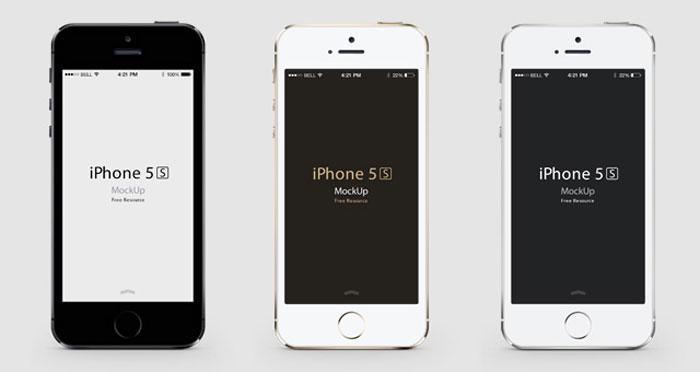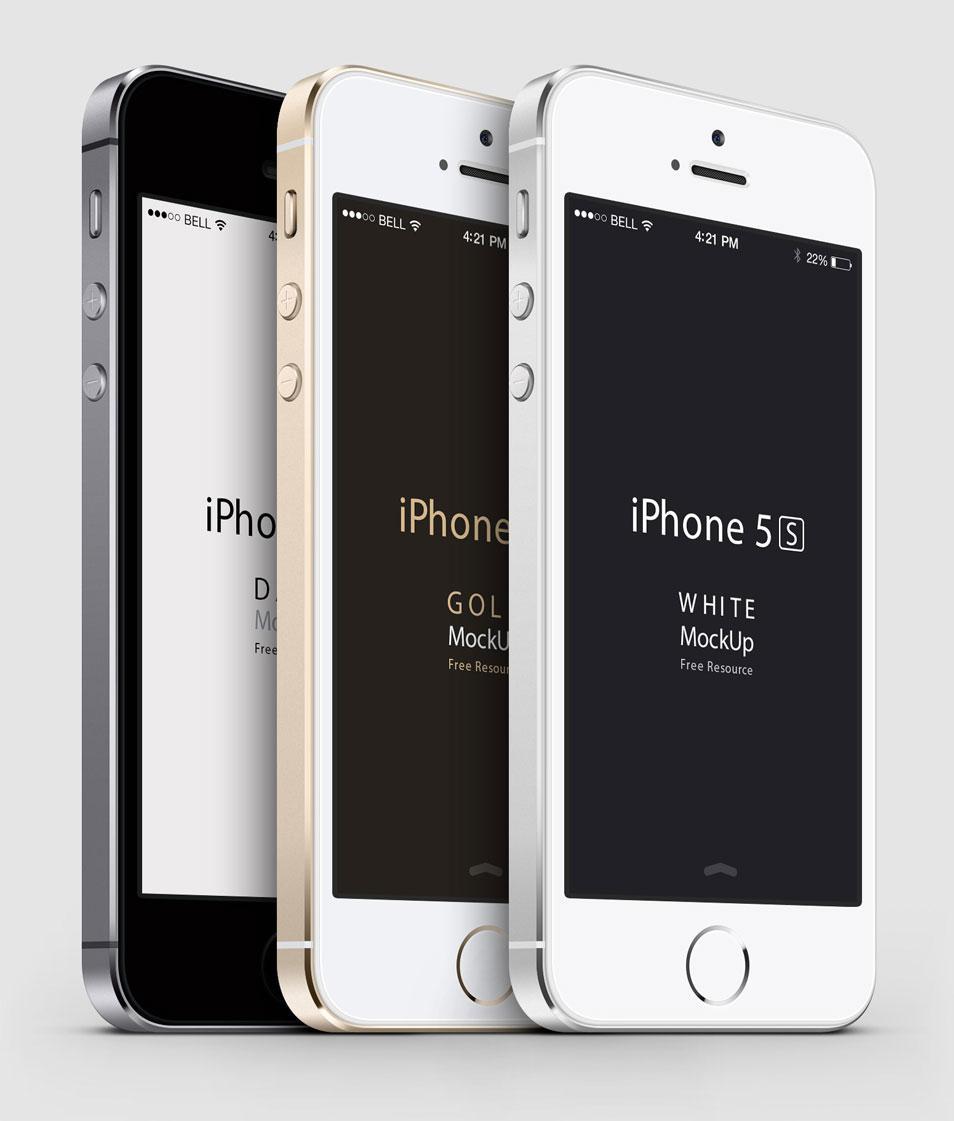The first image is the image on the left, the second image is the image on the right. For the images shown, is this caption "In one of the images you can see a screen protector being applied to the front of a smartphone." true? Answer yes or no. No. The first image is the image on the left, the second image is the image on the right. For the images shown, is this caption "The image on the left shows a screen protector hovering over a phone." true? Answer yes or no. No. 